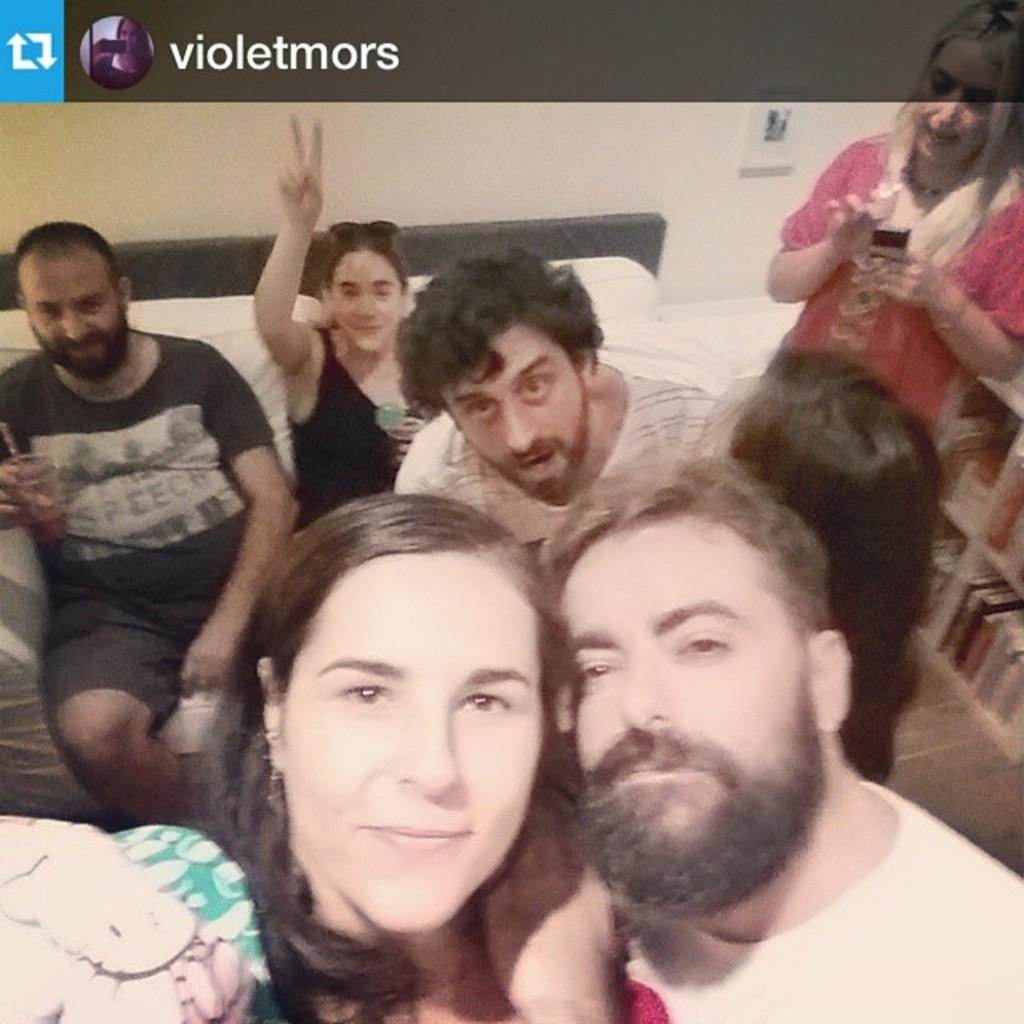How many people are in the image? There are few persons in the image. What piece of furniture is at the bottom of the image? There is a sofa at the bottom of the image. What can be seen in the background of the image? There is a wall in the background of the image. What type of truck is parked next to the sofa in the image? There is no truck present in the image; it only features a sofa and a wall in the background. 